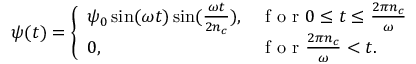Convert formula to latex. <formula><loc_0><loc_0><loc_500><loc_500>\psi ( t ) = \left \{ \begin{array} { l l } { \psi _ { 0 } \sin ( \omega t ) \sin ( \frac { \omega t } { 2 n _ { c } } ) , } & { f o r 0 \leq t \leq \frac { 2 \pi n _ { c } } { \omega } } \\ { 0 , } & { f o r \frac { 2 \pi n _ { c } } { \omega } < t . } \end{array}</formula> 